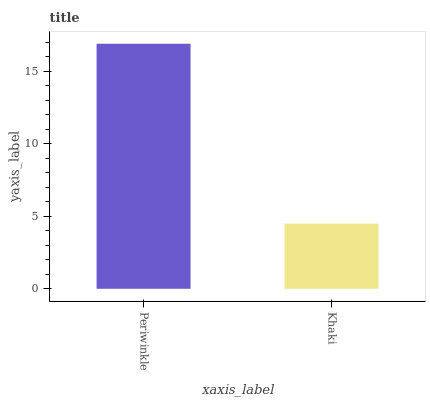Is Khaki the maximum?
Answer yes or no. No. Is Periwinkle greater than Khaki?
Answer yes or no. Yes. Is Khaki less than Periwinkle?
Answer yes or no. Yes. Is Khaki greater than Periwinkle?
Answer yes or no. No. Is Periwinkle less than Khaki?
Answer yes or no. No. Is Periwinkle the high median?
Answer yes or no. Yes. Is Khaki the low median?
Answer yes or no. Yes. Is Khaki the high median?
Answer yes or no. No. Is Periwinkle the low median?
Answer yes or no. No. 